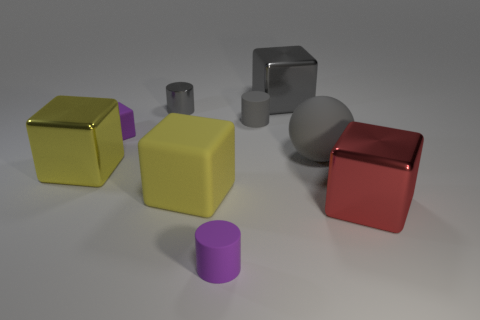How big is the shiny thing that is both to the right of the small gray metallic cylinder and in front of the small metal cylinder?
Your answer should be very brief. Large. What shape is the yellow shiny thing?
Offer a very short reply. Cube. Is there a gray thing that is on the right side of the tiny purple thing to the right of the large matte block?
Ensure brevity in your answer.  Yes. There is a big gray object that is in front of the gray metallic block; what number of large red shiny blocks are to the left of it?
Provide a short and direct response. 0. There is a red object that is the same size as the yellow metal thing; what material is it?
Offer a very short reply. Metal. There is a big yellow object that is right of the tiny metallic thing; is its shape the same as the tiny gray matte object?
Ensure brevity in your answer.  No. Is the number of red metal cubes that are right of the red block greater than the number of big gray things on the right side of the big gray rubber object?
Your response must be concise. No. What number of small green cubes have the same material as the large gray block?
Keep it short and to the point. 0. Do the red shiny block and the yellow metal block have the same size?
Your answer should be very brief. Yes. What is the color of the small shiny cylinder?
Offer a very short reply. Gray. 